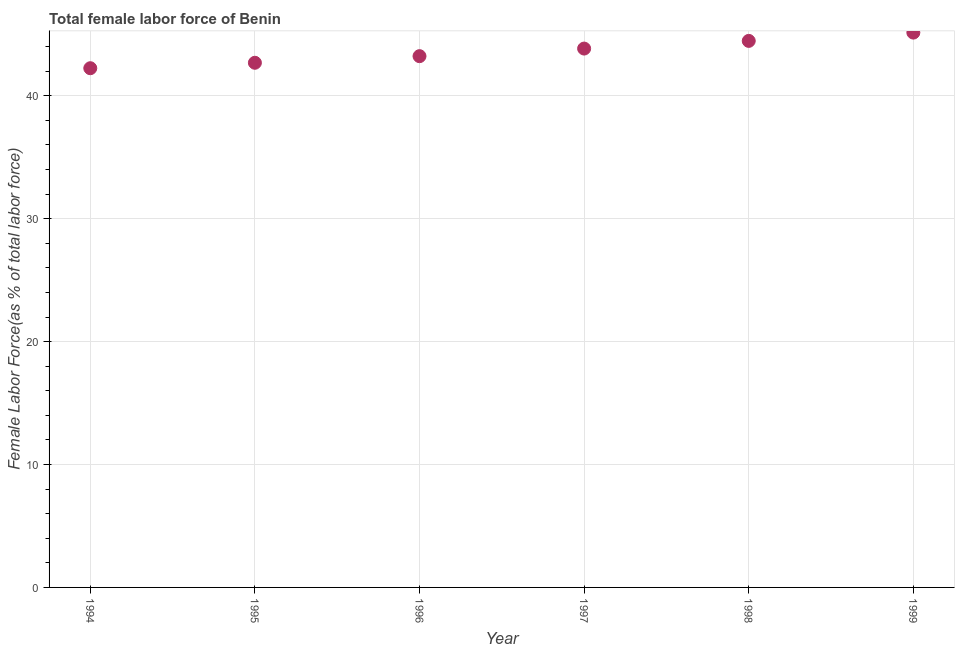What is the total female labor force in 1996?
Your response must be concise. 43.22. Across all years, what is the maximum total female labor force?
Make the answer very short. 45.14. Across all years, what is the minimum total female labor force?
Your answer should be very brief. 42.24. In which year was the total female labor force maximum?
Your answer should be compact. 1999. In which year was the total female labor force minimum?
Ensure brevity in your answer.  1994. What is the sum of the total female labor force?
Give a very brief answer. 261.6. What is the difference between the total female labor force in 1998 and 1999?
Make the answer very short. -0.67. What is the average total female labor force per year?
Your response must be concise. 43.6. What is the median total female labor force?
Give a very brief answer. 43.53. What is the ratio of the total female labor force in 1994 to that in 1995?
Ensure brevity in your answer.  0.99. Is the total female labor force in 1995 less than that in 1997?
Provide a short and direct response. Yes. Is the difference between the total female labor force in 1995 and 1999 greater than the difference between any two years?
Make the answer very short. No. What is the difference between the highest and the second highest total female labor force?
Ensure brevity in your answer.  0.67. What is the difference between the highest and the lowest total female labor force?
Offer a terse response. 2.9. In how many years, is the total female labor force greater than the average total female labor force taken over all years?
Keep it short and to the point. 3. What is the difference between two consecutive major ticks on the Y-axis?
Make the answer very short. 10. Are the values on the major ticks of Y-axis written in scientific E-notation?
Your answer should be compact. No. What is the title of the graph?
Provide a succinct answer. Total female labor force of Benin. What is the label or title of the X-axis?
Your answer should be compact. Year. What is the label or title of the Y-axis?
Make the answer very short. Female Labor Force(as % of total labor force). What is the Female Labor Force(as % of total labor force) in 1994?
Keep it short and to the point. 42.24. What is the Female Labor Force(as % of total labor force) in 1995?
Offer a terse response. 42.69. What is the Female Labor Force(as % of total labor force) in 1996?
Make the answer very short. 43.22. What is the Female Labor Force(as % of total labor force) in 1997?
Offer a very short reply. 43.84. What is the Female Labor Force(as % of total labor force) in 1998?
Make the answer very short. 44.47. What is the Female Labor Force(as % of total labor force) in 1999?
Give a very brief answer. 45.14. What is the difference between the Female Labor Force(as % of total labor force) in 1994 and 1995?
Provide a succinct answer. -0.44. What is the difference between the Female Labor Force(as % of total labor force) in 1994 and 1996?
Provide a short and direct response. -0.98. What is the difference between the Female Labor Force(as % of total labor force) in 1994 and 1997?
Your answer should be compact. -1.6. What is the difference between the Female Labor Force(as % of total labor force) in 1994 and 1998?
Make the answer very short. -2.22. What is the difference between the Female Labor Force(as % of total labor force) in 1994 and 1999?
Offer a terse response. -2.9. What is the difference between the Female Labor Force(as % of total labor force) in 1995 and 1996?
Your response must be concise. -0.54. What is the difference between the Female Labor Force(as % of total labor force) in 1995 and 1997?
Provide a short and direct response. -1.16. What is the difference between the Female Labor Force(as % of total labor force) in 1995 and 1998?
Your answer should be compact. -1.78. What is the difference between the Female Labor Force(as % of total labor force) in 1995 and 1999?
Ensure brevity in your answer.  -2.45. What is the difference between the Female Labor Force(as % of total labor force) in 1996 and 1997?
Provide a short and direct response. -0.62. What is the difference between the Female Labor Force(as % of total labor force) in 1996 and 1998?
Provide a short and direct response. -1.24. What is the difference between the Female Labor Force(as % of total labor force) in 1996 and 1999?
Give a very brief answer. -1.92. What is the difference between the Female Labor Force(as % of total labor force) in 1997 and 1998?
Offer a very short reply. -0.62. What is the difference between the Female Labor Force(as % of total labor force) in 1997 and 1999?
Provide a short and direct response. -1.3. What is the difference between the Female Labor Force(as % of total labor force) in 1998 and 1999?
Provide a succinct answer. -0.67. What is the ratio of the Female Labor Force(as % of total labor force) in 1994 to that in 1998?
Provide a short and direct response. 0.95. What is the ratio of the Female Labor Force(as % of total labor force) in 1994 to that in 1999?
Make the answer very short. 0.94. What is the ratio of the Female Labor Force(as % of total labor force) in 1995 to that in 1996?
Your answer should be very brief. 0.99. What is the ratio of the Female Labor Force(as % of total labor force) in 1995 to that in 1997?
Keep it short and to the point. 0.97. What is the ratio of the Female Labor Force(as % of total labor force) in 1995 to that in 1999?
Ensure brevity in your answer.  0.95. What is the ratio of the Female Labor Force(as % of total labor force) in 1996 to that in 1999?
Your answer should be compact. 0.96. 